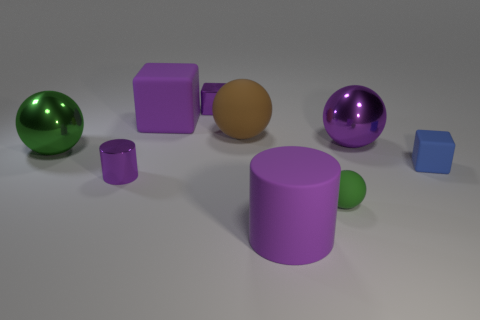Does the shiny cylinder have the same color as the small metal cube?
Your answer should be compact. Yes. Are there fewer metal balls than tiny cyan metallic cubes?
Provide a short and direct response. No. What is the color of the tiny object that is behind the large purple matte cube that is left of the green matte ball?
Provide a short and direct response. Purple. There is another tiny thing that is the same shape as the tiny blue rubber thing; what is its material?
Your answer should be very brief. Metal. What number of matte things are small purple cubes or yellow balls?
Provide a succinct answer. 0. Is the material of the big ball on the left side of the purple rubber cube the same as the big object that is in front of the green metallic thing?
Your answer should be very brief. No. Are there any gray matte cubes?
Your answer should be very brief. No. There is a tiny matte object left of the purple shiny sphere; does it have the same shape as the large metal thing on the left side of the purple matte cylinder?
Your response must be concise. Yes. Are there any green things made of the same material as the big brown sphere?
Provide a succinct answer. Yes. Do the tiny cube that is left of the big cylinder and the small blue block have the same material?
Offer a terse response. No. 